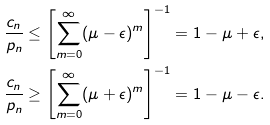<formula> <loc_0><loc_0><loc_500><loc_500>\frac { c _ { n } } { p _ { n } } & \leq \left [ \sum _ { m = 0 } ^ { \infty } ( \mu - \epsilon ) ^ { m } \right ] ^ { - 1 } = 1 - \mu + \epsilon , \\ \frac { c _ { n } } { p _ { n } } & \geq \left [ \sum _ { m = 0 } ^ { \infty } ( \mu + \epsilon ) ^ { m } \right ] ^ { - 1 } = 1 - \mu - \epsilon .</formula> 